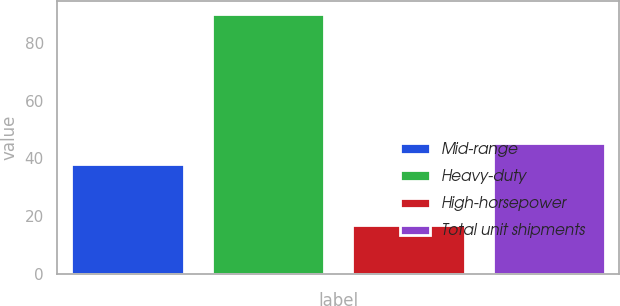Convert chart to OTSL. <chart><loc_0><loc_0><loc_500><loc_500><bar_chart><fcel>Mid-range<fcel>Heavy-duty<fcel>High-horsepower<fcel>Total unit shipments<nl><fcel>38<fcel>90<fcel>17<fcel>45.3<nl></chart> 